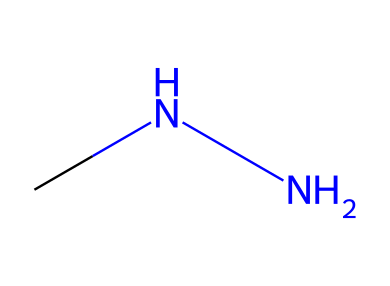What is the molecular formula of methylhydrazine? The SMILES representation "CNN" indicates that there are three atoms present: two nitrogen (N) and four hydrogen (H) atoms surrounding a carbon (C) atom. Therefore, the total molecular formula can be derived as C1H8N2.
Answer: C1H8N2 How many nitrogen atoms are in methylhydrazine? By analyzing the SMILES "CNN," we can identify two nitrogen atoms connected to one carbon atom and hydrogen atoms.
Answer: 2 What type of chemical bonding is present in methylhydrazine? The SMILES structure shows only single bonds connecting the atoms (C–N and N–H), indicating the presence of covalent bonding, which is typical for organic compounds containing carbon and nitrogen.
Answer: covalent Is methylhydrazine a saturated or unsaturated compound? The presence of only single bonds in the structure conforms to the criteria for saturated compounds, which have no double or triple bonds. Thus, methylhydrazine is classified as saturated.
Answer: saturated What functional group is associated with hydrazines like methylhydrazine? The structure of methylhydrazine contains an amine functionality due to the presence of nitrogen, highlighting its classification within the hydrazines.
Answer: amine What potential health hazard is associated with methylhydrazine? Methylhydrazine is toxic and can cause health issues, including skin and respiratory irritation, and is classified as a potential environmental contaminant in various systems.
Answer: toxic What is the common use of methylhydrazine in terms of its properties? Due to its properties, methylhydrazine is commonly used as a rocket propellant, taking advantage of its highly reactive nature.
Answer: rocket propellant 